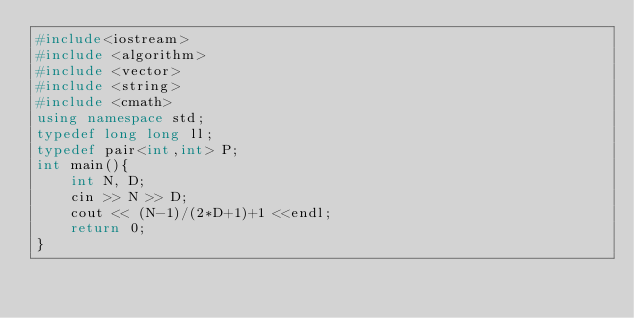<code> <loc_0><loc_0><loc_500><loc_500><_C++_>#include<iostream>
#include <algorithm>
#include <vector>
#include <string>
#include <cmath>
using namespace std;
typedef long long ll;
typedef pair<int,int> P;
int main(){
  	int N, D;  	
    cin >> N >> D;
    cout << (N-1)/(2*D+1)+1 <<endl;
    return 0;
}

</code> 